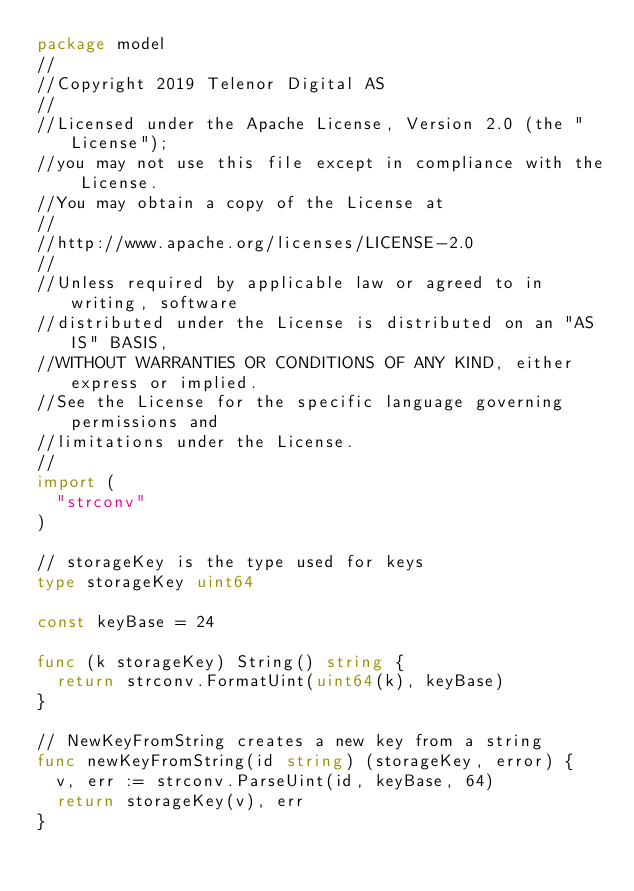<code> <loc_0><loc_0><loc_500><loc_500><_Go_>package model
//
//Copyright 2019 Telenor Digital AS
//
//Licensed under the Apache License, Version 2.0 (the "License");
//you may not use this file except in compliance with the License.
//You may obtain a copy of the License at
//
//http://www.apache.org/licenses/LICENSE-2.0
//
//Unless required by applicable law or agreed to in writing, software
//distributed under the License is distributed on an "AS IS" BASIS,
//WITHOUT WARRANTIES OR CONDITIONS OF ANY KIND, either express or implied.
//See the License for the specific language governing permissions and
//limitations under the License.
//
import (
	"strconv"
)

// storageKey is the type used for keys
type storageKey uint64

const keyBase = 24

func (k storageKey) String() string {
	return strconv.FormatUint(uint64(k), keyBase)
}

// NewKeyFromString creates a new key from a string
func newKeyFromString(id string) (storageKey, error) {
	v, err := strconv.ParseUint(id, keyBase, 64)
	return storageKey(v), err
}
</code> 